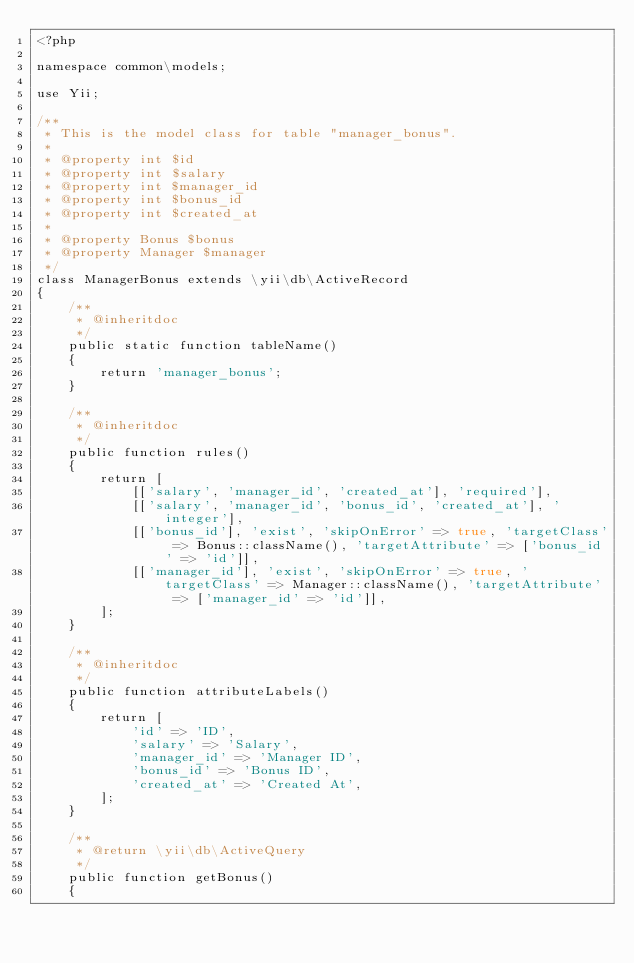<code> <loc_0><loc_0><loc_500><loc_500><_PHP_><?php

namespace common\models;

use Yii;

/**
 * This is the model class for table "manager_bonus".
 *
 * @property int $id
 * @property int $salary
 * @property int $manager_id
 * @property int $bonus_id
 * @property int $created_at
 *
 * @property Bonus $bonus
 * @property Manager $manager
 */
class ManagerBonus extends \yii\db\ActiveRecord
{
    /**
     * @inheritdoc
     */
    public static function tableName()
    {
        return 'manager_bonus';
    }

    /**
     * @inheritdoc
     */
    public function rules()
    {
        return [
            [['salary', 'manager_id', 'created_at'], 'required'],
            [['salary', 'manager_id', 'bonus_id', 'created_at'], 'integer'],
            [['bonus_id'], 'exist', 'skipOnError' => true, 'targetClass' => Bonus::className(), 'targetAttribute' => ['bonus_id' => 'id']],
            [['manager_id'], 'exist', 'skipOnError' => true, 'targetClass' => Manager::className(), 'targetAttribute' => ['manager_id' => 'id']],
        ];
    }

    /**
     * @inheritdoc
     */
    public function attributeLabels()
    {
        return [
            'id' => 'ID',
            'salary' => 'Salary',
            'manager_id' => 'Manager ID',
            'bonus_id' => 'Bonus ID',
            'created_at' => 'Created At',
        ];
    }

    /**
     * @return \yii\db\ActiveQuery
     */
    public function getBonus()
    {</code> 